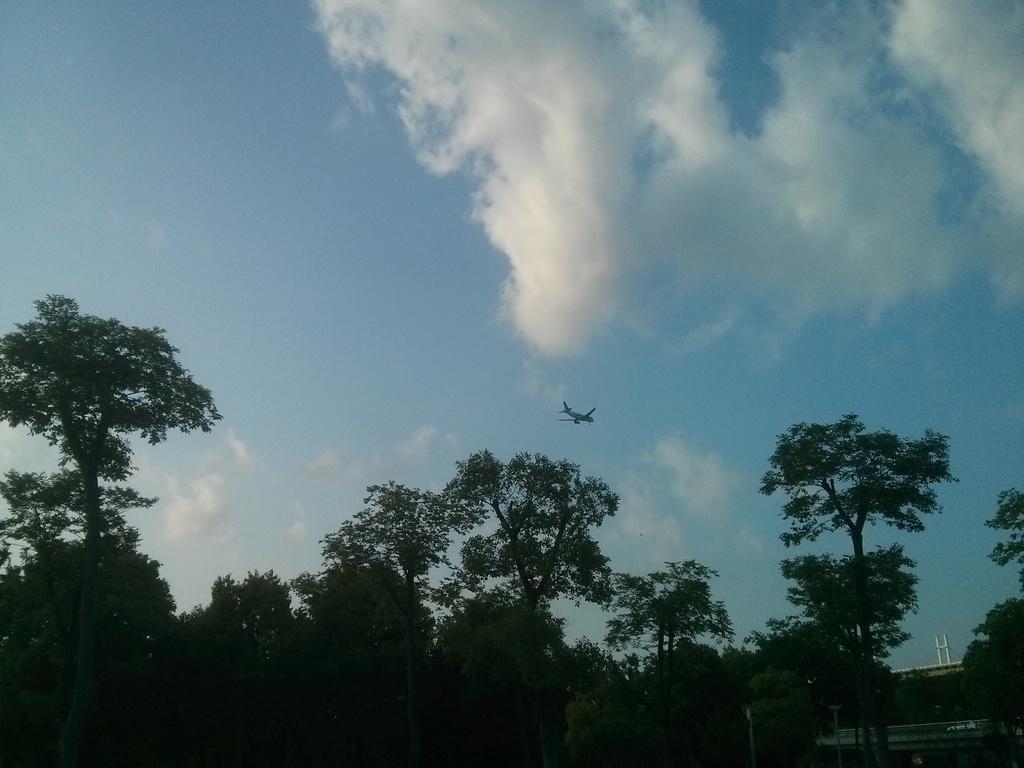Could you give a brief overview of what you see in this image? In this image I can see trees. In the background I can see an aeroplane and the sky. 